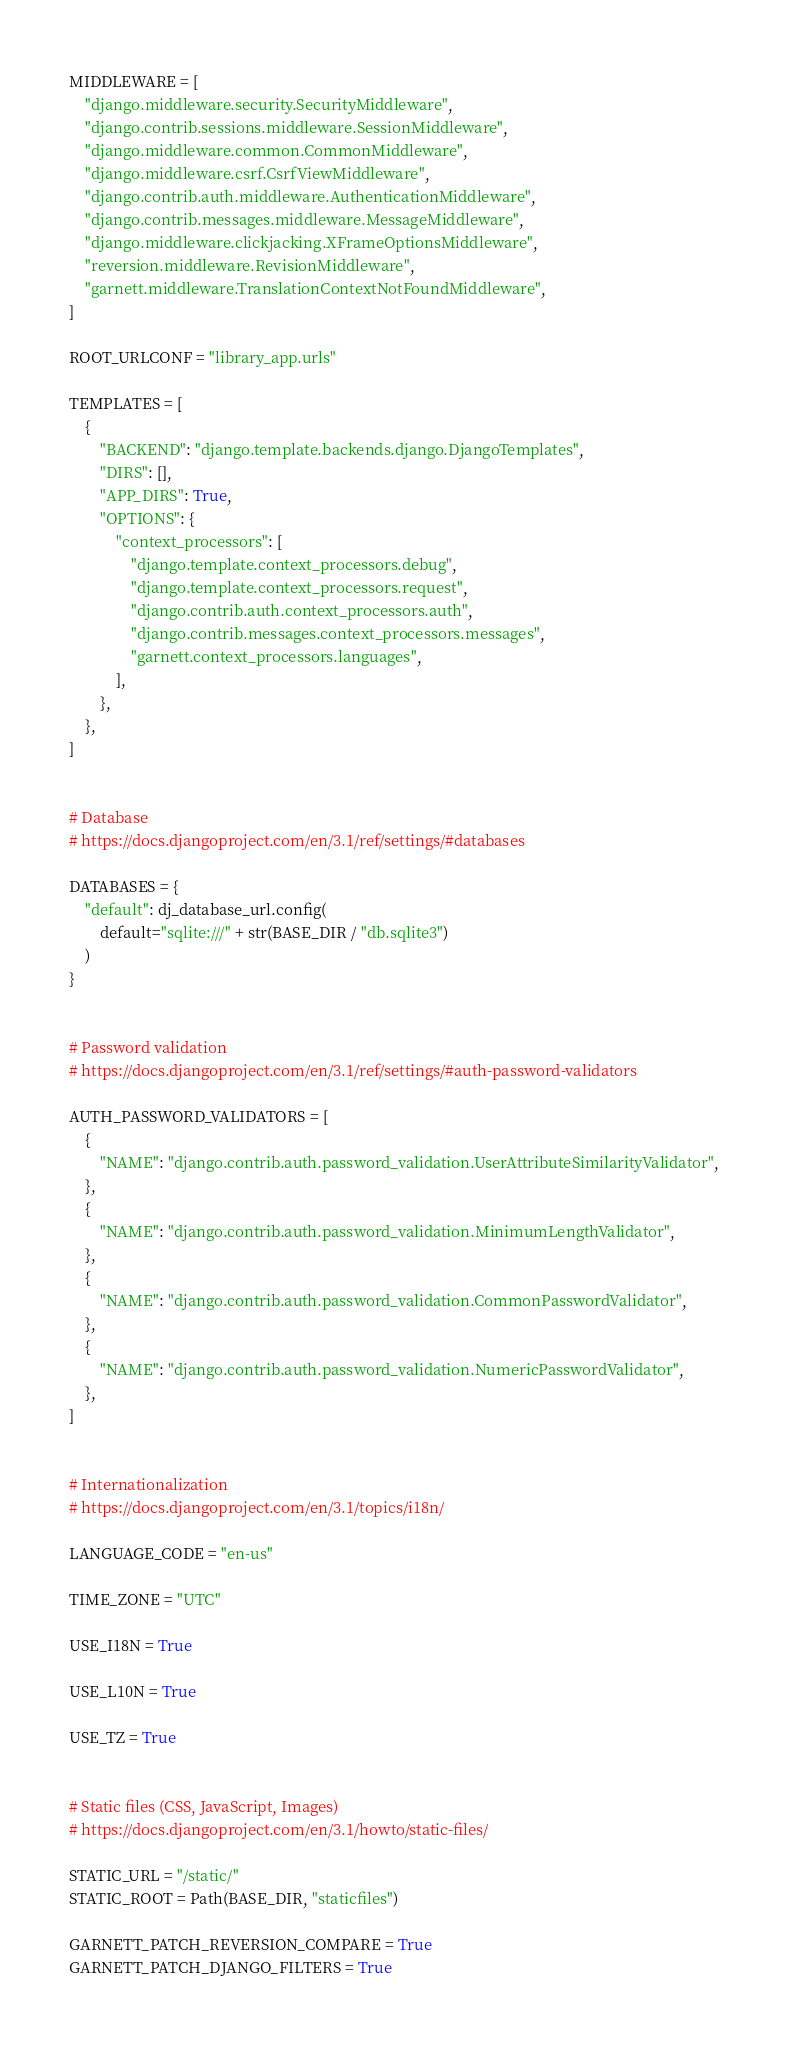Convert code to text. <code><loc_0><loc_0><loc_500><loc_500><_Python_>
MIDDLEWARE = [
    "django.middleware.security.SecurityMiddleware",
    "django.contrib.sessions.middleware.SessionMiddleware",
    "django.middleware.common.CommonMiddleware",
    "django.middleware.csrf.CsrfViewMiddleware",
    "django.contrib.auth.middleware.AuthenticationMiddleware",
    "django.contrib.messages.middleware.MessageMiddleware",
    "django.middleware.clickjacking.XFrameOptionsMiddleware",
    "reversion.middleware.RevisionMiddleware",
    "garnett.middleware.TranslationContextNotFoundMiddleware",
]

ROOT_URLCONF = "library_app.urls"

TEMPLATES = [
    {
        "BACKEND": "django.template.backends.django.DjangoTemplates",
        "DIRS": [],
        "APP_DIRS": True,
        "OPTIONS": {
            "context_processors": [
                "django.template.context_processors.debug",
                "django.template.context_processors.request",
                "django.contrib.auth.context_processors.auth",
                "django.contrib.messages.context_processors.messages",
                "garnett.context_processors.languages",
            ],
        },
    },
]


# Database
# https://docs.djangoproject.com/en/3.1/ref/settings/#databases

DATABASES = {
    "default": dj_database_url.config(
        default="sqlite:///" + str(BASE_DIR / "db.sqlite3")
    )
}


# Password validation
# https://docs.djangoproject.com/en/3.1/ref/settings/#auth-password-validators

AUTH_PASSWORD_VALIDATORS = [
    {
        "NAME": "django.contrib.auth.password_validation.UserAttributeSimilarityValidator",
    },
    {
        "NAME": "django.contrib.auth.password_validation.MinimumLengthValidator",
    },
    {
        "NAME": "django.contrib.auth.password_validation.CommonPasswordValidator",
    },
    {
        "NAME": "django.contrib.auth.password_validation.NumericPasswordValidator",
    },
]


# Internationalization
# https://docs.djangoproject.com/en/3.1/topics/i18n/

LANGUAGE_CODE = "en-us"

TIME_ZONE = "UTC"

USE_I18N = True

USE_L10N = True

USE_TZ = True


# Static files (CSS, JavaScript, Images)
# https://docs.djangoproject.com/en/3.1/howto/static-files/

STATIC_URL = "/static/"
STATIC_ROOT = Path(BASE_DIR, "staticfiles")

GARNETT_PATCH_REVERSION_COMPARE = True
GARNETT_PATCH_DJANGO_FILTERS = True
</code> 